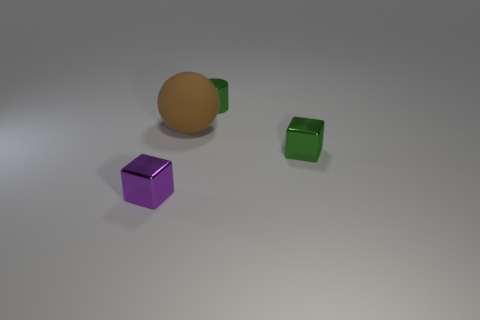Is there anything else that has the same size as the brown rubber object?
Ensure brevity in your answer.  No. What number of other objects are there of the same color as the cylinder?
Make the answer very short. 1. Are there any other things that have the same material as the large brown object?
Offer a very short reply. No. Are there any metallic blocks that have the same color as the metal cylinder?
Keep it short and to the point. Yes. There is a cylinder; does it have the same color as the cube that is right of the large brown ball?
Your response must be concise. Yes. Are there fewer brown balls that are on the right side of the cylinder than rubber objects on the left side of the purple metallic thing?
Provide a short and direct response. No. How many other objects are the same shape as the tiny purple thing?
Provide a short and direct response. 1. Are there fewer cylinders that are in front of the shiny cylinder than tiny green cylinders?
Make the answer very short. Yes. What is the material of the brown object that is behind the small green shiny block?
Keep it short and to the point. Rubber. What number of other things are there of the same size as the rubber ball?
Offer a terse response. 0. 